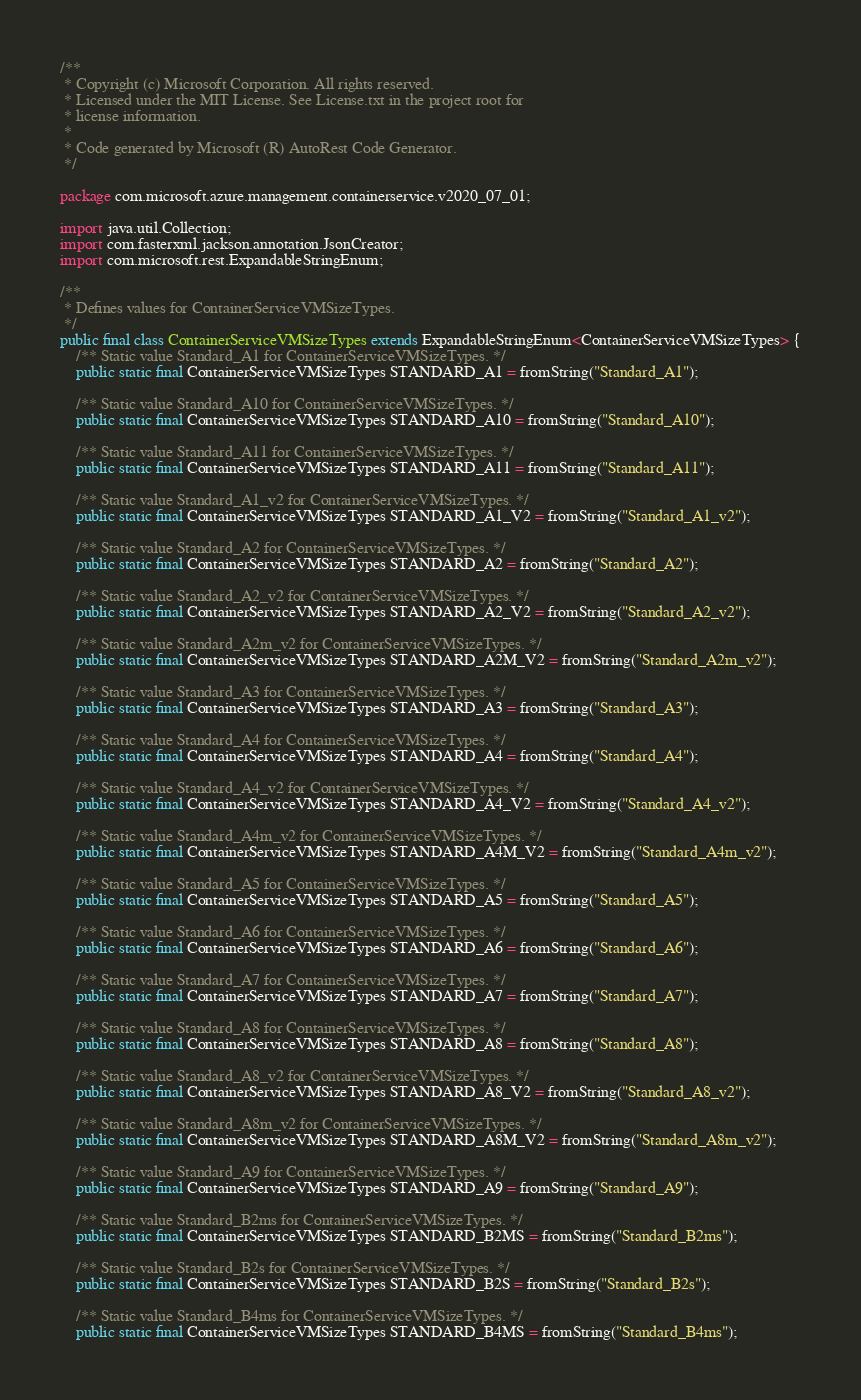Convert code to text. <code><loc_0><loc_0><loc_500><loc_500><_Java_>/**
 * Copyright (c) Microsoft Corporation. All rights reserved.
 * Licensed under the MIT License. See License.txt in the project root for
 * license information.
 *
 * Code generated by Microsoft (R) AutoRest Code Generator.
 */

package com.microsoft.azure.management.containerservice.v2020_07_01;

import java.util.Collection;
import com.fasterxml.jackson.annotation.JsonCreator;
import com.microsoft.rest.ExpandableStringEnum;

/**
 * Defines values for ContainerServiceVMSizeTypes.
 */
public final class ContainerServiceVMSizeTypes extends ExpandableStringEnum<ContainerServiceVMSizeTypes> {
    /** Static value Standard_A1 for ContainerServiceVMSizeTypes. */
    public static final ContainerServiceVMSizeTypes STANDARD_A1 = fromString("Standard_A1");

    /** Static value Standard_A10 for ContainerServiceVMSizeTypes. */
    public static final ContainerServiceVMSizeTypes STANDARD_A10 = fromString("Standard_A10");

    /** Static value Standard_A11 for ContainerServiceVMSizeTypes. */
    public static final ContainerServiceVMSizeTypes STANDARD_A11 = fromString("Standard_A11");

    /** Static value Standard_A1_v2 for ContainerServiceVMSizeTypes. */
    public static final ContainerServiceVMSizeTypes STANDARD_A1_V2 = fromString("Standard_A1_v2");

    /** Static value Standard_A2 for ContainerServiceVMSizeTypes. */
    public static final ContainerServiceVMSizeTypes STANDARD_A2 = fromString("Standard_A2");

    /** Static value Standard_A2_v2 for ContainerServiceVMSizeTypes. */
    public static final ContainerServiceVMSizeTypes STANDARD_A2_V2 = fromString("Standard_A2_v2");

    /** Static value Standard_A2m_v2 for ContainerServiceVMSizeTypes. */
    public static final ContainerServiceVMSizeTypes STANDARD_A2M_V2 = fromString("Standard_A2m_v2");

    /** Static value Standard_A3 for ContainerServiceVMSizeTypes. */
    public static final ContainerServiceVMSizeTypes STANDARD_A3 = fromString("Standard_A3");

    /** Static value Standard_A4 for ContainerServiceVMSizeTypes. */
    public static final ContainerServiceVMSizeTypes STANDARD_A4 = fromString("Standard_A4");

    /** Static value Standard_A4_v2 for ContainerServiceVMSizeTypes. */
    public static final ContainerServiceVMSizeTypes STANDARD_A4_V2 = fromString("Standard_A4_v2");

    /** Static value Standard_A4m_v2 for ContainerServiceVMSizeTypes. */
    public static final ContainerServiceVMSizeTypes STANDARD_A4M_V2 = fromString("Standard_A4m_v2");

    /** Static value Standard_A5 for ContainerServiceVMSizeTypes. */
    public static final ContainerServiceVMSizeTypes STANDARD_A5 = fromString("Standard_A5");

    /** Static value Standard_A6 for ContainerServiceVMSizeTypes. */
    public static final ContainerServiceVMSizeTypes STANDARD_A6 = fromString("Standard_A6");

    /** Static value Standard_A7 for ContainerServiceVMSizeTypes. */
    public static final ContainerServiceVMSizeTypes STANDARD_A7 = fromString("Standard_A7");

    /** Static value Standard_A8 for ContainerServiceVMSizeTypes. */
    public static final ContainerServiceVMSizeTypes STANDARD_A8 = fromString("Standard_A8");

    /** Static value Standard_A8_v2 for ContainerServiceVMSizeTypes. */
    public static final ContainerServiceVMSizeTypes STANDARD_A8_V2 = fromString("Standard_A8_v2");

    /** Static value Standard_A8m_v2 for ContainerServiceVMSizeTypes. */
    public static final ContainerServiceVMSizeTypes STANDARD_A8M_V2 = fromString("Standard_A8m_v2");

    /** Static value Standard_A9 for ContainerServiceVMSizeTypes. */
    public static final ContainerServiceVMSizeTypes STANDARD_A9 = fromString("Standard_A9");

    /** Static value Standard_B2ms for ContainerServiceVMSizeTypes. */
    public static final ContainerServiceVMSizeTypes STANDARD_B2MS = fromString("Standard_B2ms");

    /** Static value Standard_B2s for ContainerServiceVMSizeTypes. */
    public static final ContainerServiceVMSizeTypes STANDARD_B2S = fromString("Standard_B2s");

    /** Static value Standard_B4ms for ContainerServiceVMSizeTypes. */
    public static final ContainerServiceVMSizeTypes STANDARD_B4MS = fromString("Standard_B4ms");
</code> 